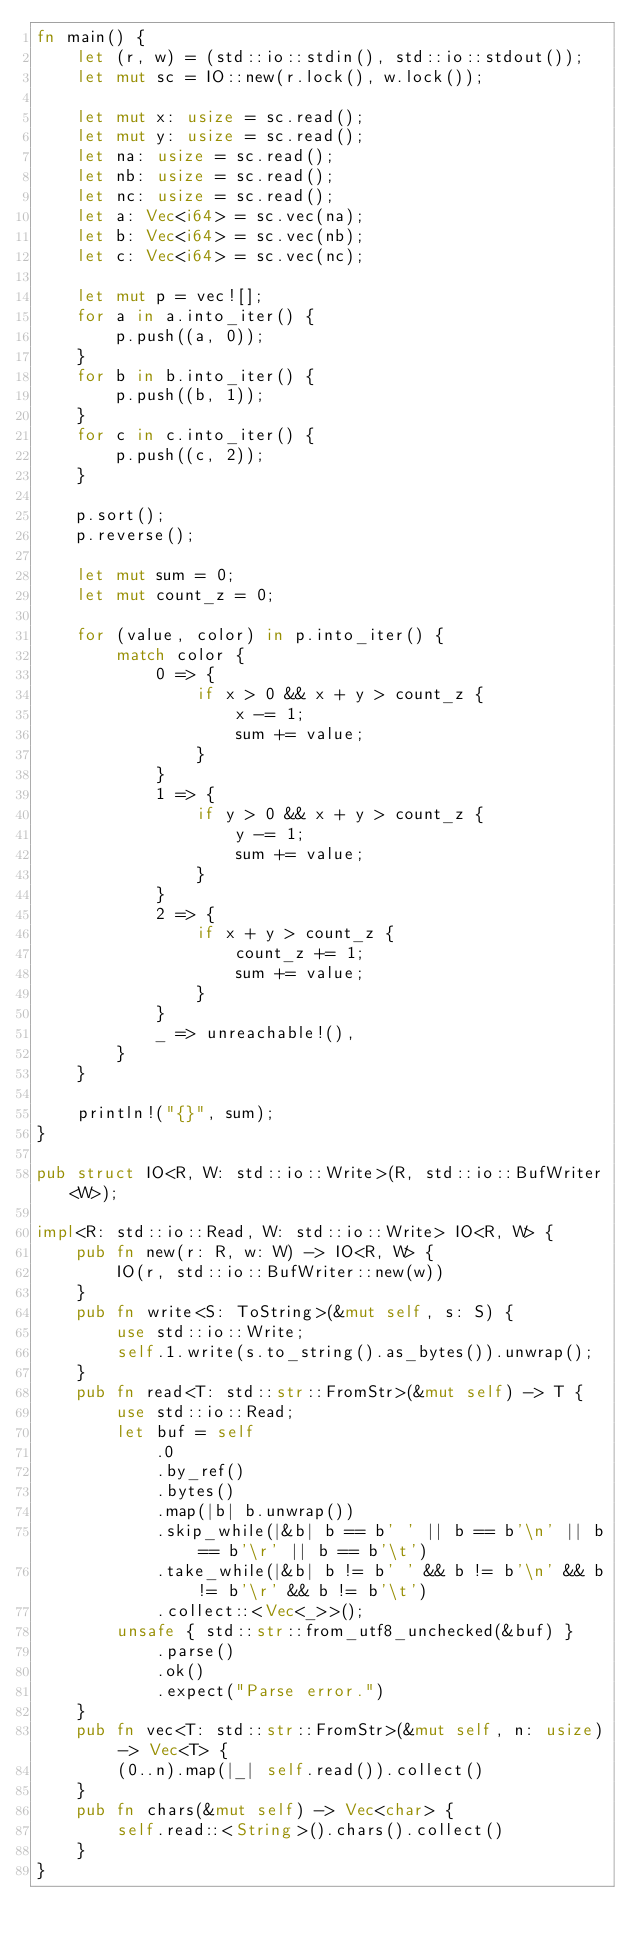<code> <loc_0><loc_0><loc_500><loc_500><_Rust_>fn main() {
    let (r, w) = (std::io::stdin(), std::io::stdout());
    let mut sc = IO::new(r.lock(), w.lock());

    let mut x: usize = sc.read();
    let mut y: usize = sc.read();
    let na: usize = sc.read();
    let nb: usize = sc.read();
    let nc: usize = sc.read();
    let a: Vec<i64> = sc.vec(na);
    let b: Vec<i64> = sc.vec(nb);
    let c: Vec<i64> = sc.vec(nc);

    let mut p = vec![];
    for a in a.into_iter() {
        p.push((a, 0));
    }
    for b in b.into_iter() {
        p.push((b, 1));
    }
    for c in c.into_iter() {
        p.push((c, 2));
    }

    p.sort();
    p.reverse();

    let mut sum = 0;
    let mut count_z = 0;

    for (value, color) in p.into_iter() {
        match color {
            0 => {
                if x > 0 && x + y > count_z {
                    x -= 1;
                    sum += value;
                }
            }
            1 => {
                if y > 0 && x + y > count_z {
                    y -= 1;
                    sum += value;
                }
            }
            2 => {
                if x + y > count_z {
                    count_z += 1;
                    sum += value;
                }
            }
            _ => unreachable!(),
        }
    }

    println!("{}", sum);
}

pub struct IO<R, W: std::io::Write>(R, std::io::BufWriter<W>);

impl<R: std::io::Read, W: std::io::Write> IO<R, W> {
    pub fn new(r: R, w: W) -> IO<R, W> {
        IO(r, std::io::BufWriter::new(w))
    }
    pub fn write<S: ToString>(&mut self, s: S) {
        use std::io::Write;
        self.1.write(s.to_string().as_bytes()).unwrap();
    }
    pub fn read<T: std::str::FromStr>(&mut self) -> T {
        use std::io::Read;
        let buf = self
            .0
            .by_ref()
            .bytes()
            .map(|b| b.unwrap())
            .skip_while(|&b| b == b' ' || b == b'\n' || b == b'\r' || b == b'\t')
            .take_while(|&b| b != b' ' && b != b'\n' && b != b'\r' && b != b'\t')
            .collect::<Vec<_>>();
        unsafe { std::str::from_utf8_unchecked(&buf) }
            .parse()
            .ok()
            .expect("Parse error.")
    }
    pub fn vec<T: std::str::FromStr>(&mut self, n: usize) -> Vec<T> {
        (0..n).map(|_| self.read()).collect()
    }
    pub fn chars(&mut self) -> Vec<char> {
        self.read::<String>().chars().collect()
    }
}
</code> 